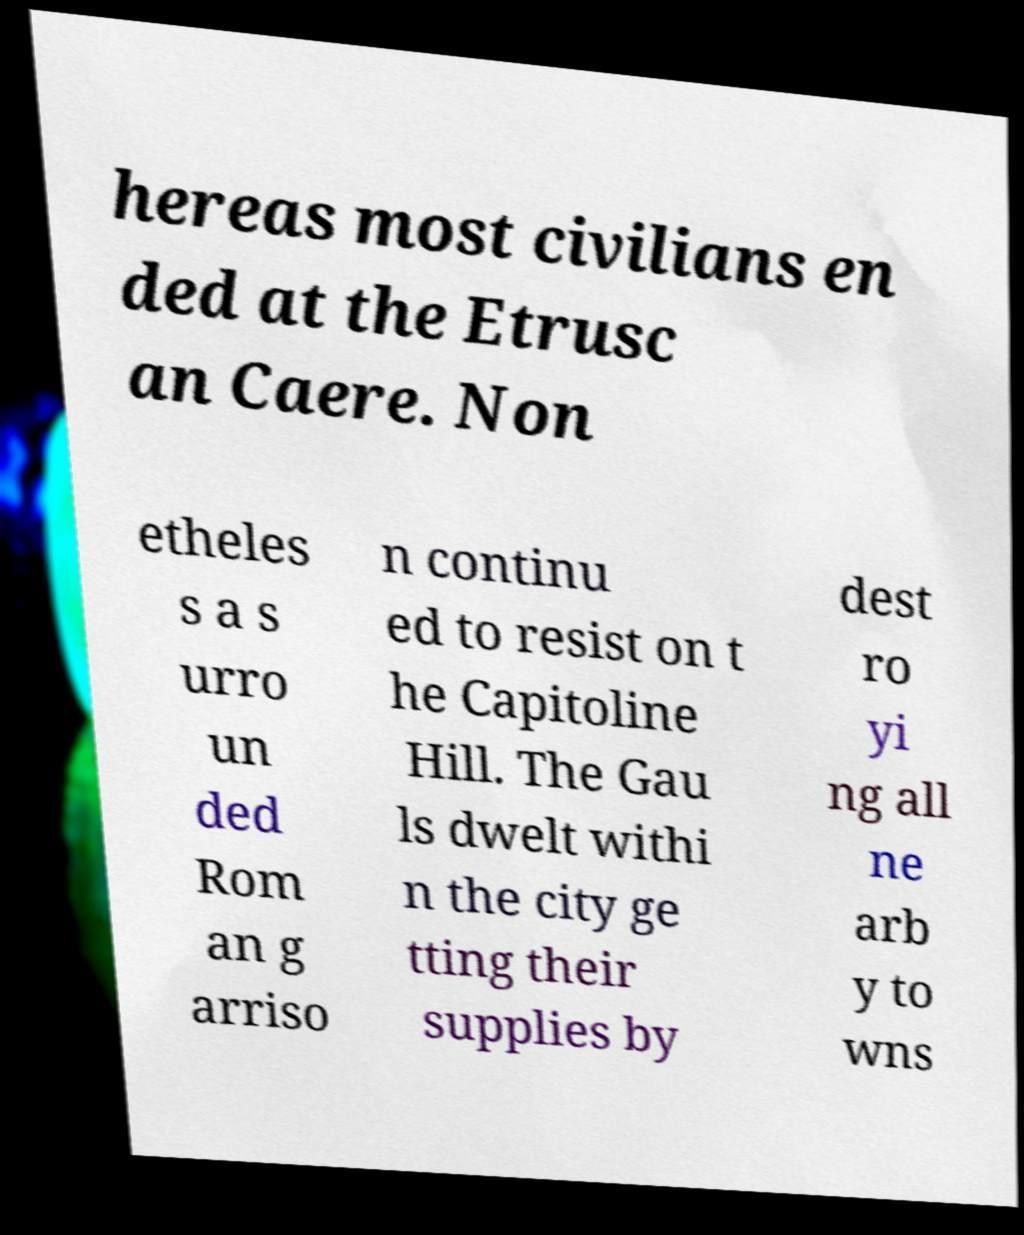What messages or text are displayed in this image? I need them in a readable, typed format. hereas most civilians en ded at the Etrusc an Caere. Non etheles s a s urro un ded Rom an g arriso n continu ed to resist on t he Capitoline Hill. The Gau ls dwelt withi n the city ge tting their supplies by dest ro yi ng all ne arb y to wns 